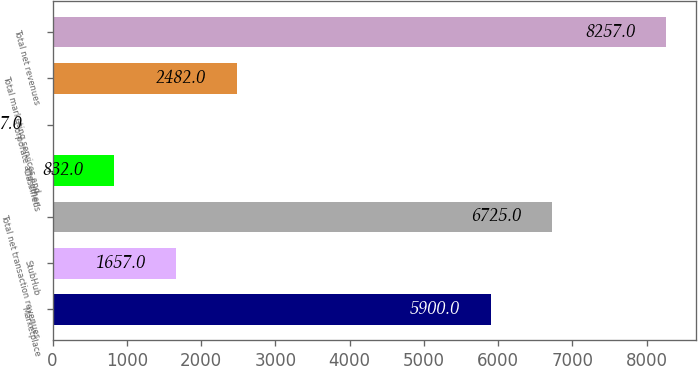<chart> <loc_0><loc_0><loc_500><loc_500><bar_chart><fcel>Marketplace<fcel>StubHub<fcel>Total net transaction revenues<fcel>Classifieds<fcel>Corporate and other<fcel>Total marketing services and<fcel>Total net revenues<nl><fcel>5900<fcel>1657<fcel>6725<fcel>832<fcel>7<fcel>2482<fcel>8257<nl></chart> 